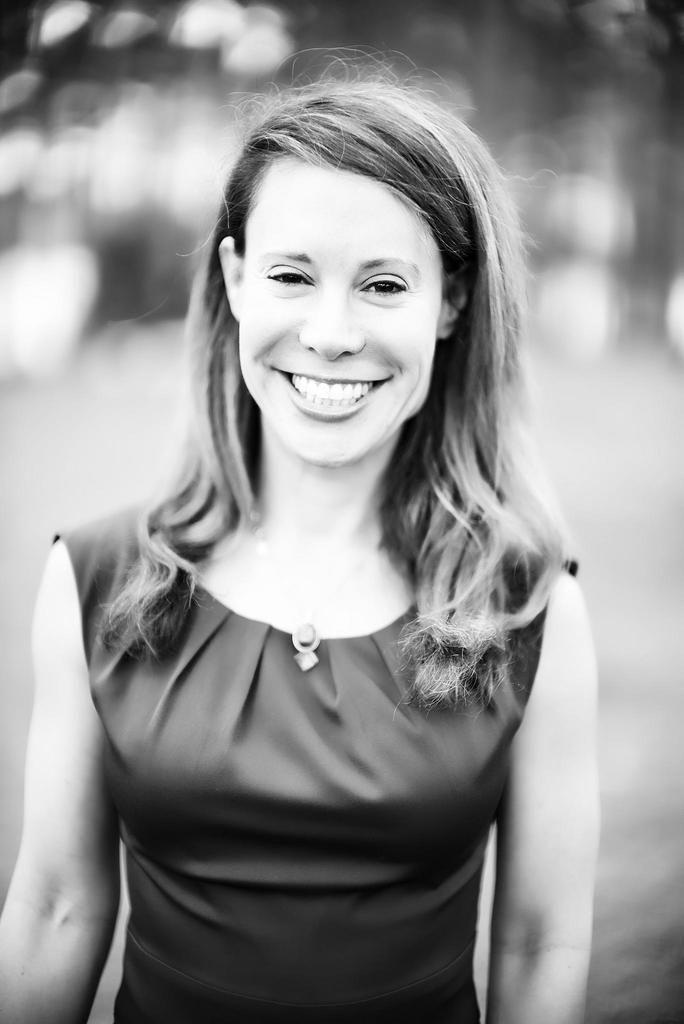Please provide a concise description of this image. This is a black and white image , as we can see there is one woman standing and smiling in the middle of this image. 